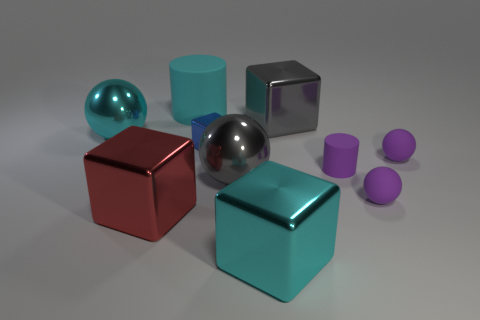Is there a small shiny block of the same color as the small metal thing?
Ensure brevity in your answer.  No. How big is the gray object in front of the large gray shiny thing right of the big cyan object that is in front of the large red thing?
Keep it short and to the point. Large. What shape is the red object?
Your answer should be very brief. Cube. What is the size of the block that is the same color as the large matte thing?
Give a very brief answer. Large. How many big cyan rubber objects are on the right side of the cyan object on the left side of the big cyan cylinder?
Offer a very short reply. 1. How many other objects are the same material as the tiny cube?
Keep it short and to the point. 5. Do the cyan thing that is right of the large cyan matte thing and the cyan object that is behind the large cyan ball have the same material?
Your answer should be compact. No. Are there any other things that have the same shape as the blue thing?
Make the answer very short. Yes. Do the red object and the cylinder behind the big cyan shiny sphere have the same material?
Give a very brief answer. No. There is a rubber ball behind the big sphere that is right of the cyan shiny object to the left of the blue shiny thing; what is its color?
Provide a succinct answer. Purple. 